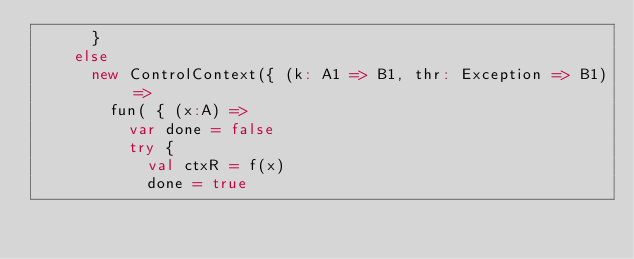Convert code to text. <code><loc_0><loc_0><loc_500><loc_500><_Scala_>      }
    else
      new ControlContext({ (k: A1 => B1, thr: Exception => B1) =>
        fun( { (x:A) =>
          var done = false
          try {
            val ctxR = f(x)
            done = true</code> 